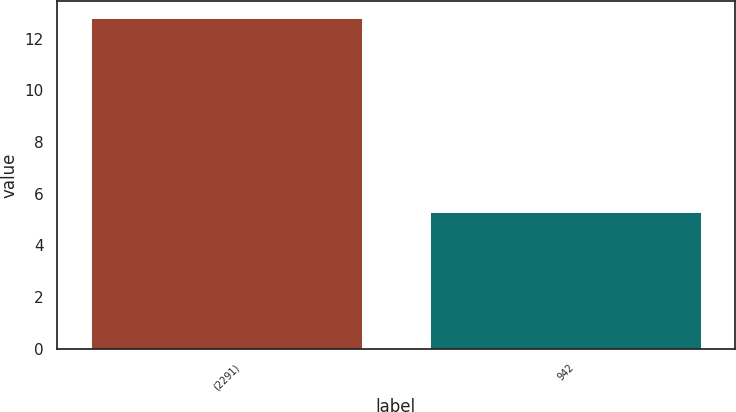Convert chart to OTSL. <chart><loc_0><loc_0><loc_500><loc_500><bar_chart><fcel>(2291)<fcel>942<nl><fcel>12.8<fcel>5.3<nl></chart> 